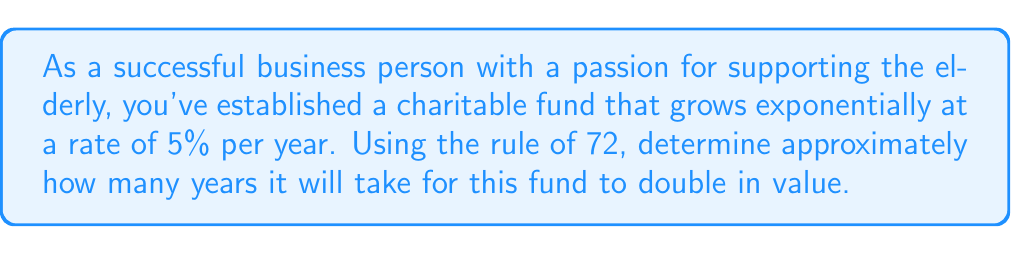Help me with this question. To solve this problem, we'll use the Rule of 72, which is a simple way to estimate the time required for an investment to double when it grows at a compound interest rate.

The Rule of 72 states that:

$$ T \approx \frac{72}{r} $$

Where:
- $T$ is the time required for the investment to double
- $r$ is the annual growth rate expressed as a percentage

In this case:
- $r = 5\%$ (given in the question)

Let's substitute this into the formula:

$$ T \approx \frac{72}{5} $$

$$ T \approx 14.4 $$

Since we're dealing with years, we'll round to the nearest whole number:

$$ T \approx 14 \text{ years} $$

It's important to note that the Rule of 72 is an approximation. For more precise calculations, we would use the exact formula:

$$ T = \frac{\ln(2)}{\ln(1 + \frac{r}{100})} $$

Using this formula with $r = 5$, we get:

$$ T = \frac{\ln(2)}{\ln(1.05)} \approx 14.2067 \text{ years} $$

This confirms that our approximation using the Rule of 72 is quite accurate for this growth rate.
Answer: Approximately 14 years 